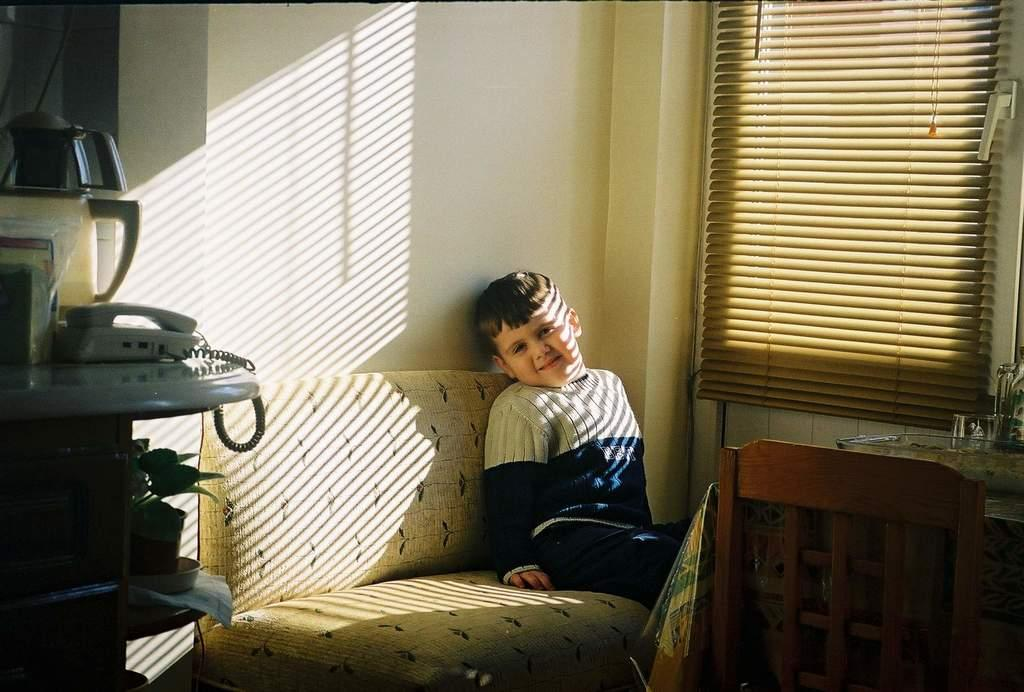Who is the main subject in the image? There is a boy in the image. What is the boy doing in the image? The boy is sitting on a sofa. What other furniture is present in the image? There is a table in the image. Where is the table located in relation to the window? The table is beside a window. How many rings does the crow have on its beak in the image? There is no crow present in the image, and therefore no rings on its beak. 